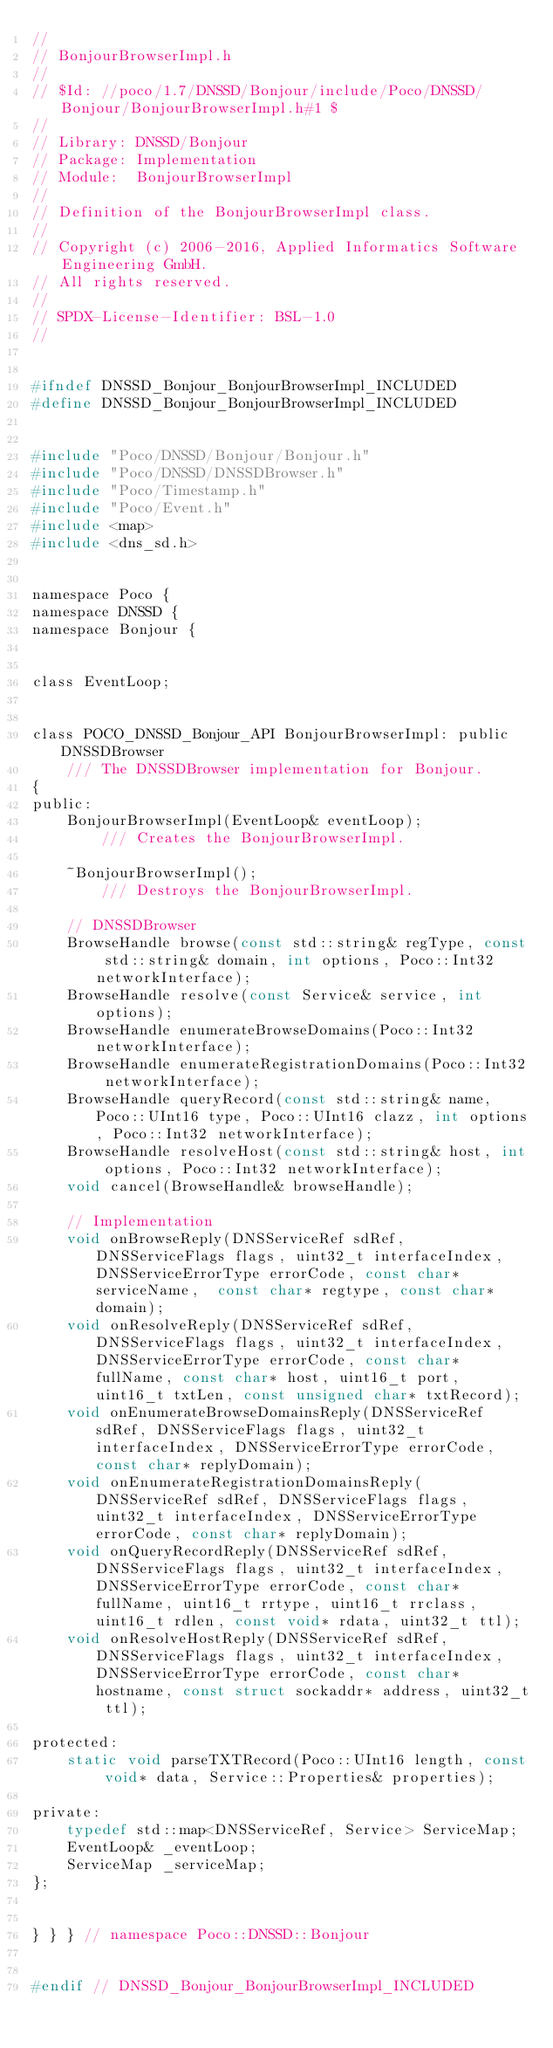<code> <loc_0><loc_0><loc_500><loc_500><_C_>//
// BonjourBrowserImpl.h
//
// $Id: //poco/1.7/DNSSD/Bonjour/include/Poco/DNSSD/Bonjour/BonjourBrowserImpl.h#1 $
//
// Library: DNSSD/Bonjour
// Package: Implementation
// Module:  BonjourBrowserImpl
//
// Definition of the BonjourBrowserImpl class.
//
// Copyright (c) 2006-2016, Applied Informatics Software Engineering GmbH.
// All rights reserved.
//
// SPDX-License-Identifier:	BSL-1.0
//


#ifndef DNSSD_Bonjour_BonjourBrowserImpl_INCLUDED
#define DNSSD_Bonjour_BonjourBrowserImpl_INCLUDED


#include "Poco/DNSSD/Bonjour/Bonjour.h"
#include "Poco/DNSSD/DNSSDBrowser.h"
#include "Poco/Timestamp.h"
#include "Poco/Event.h"
#include <map>
#include <dns_sd.h>


namespace Poco {
namespace DNSSD {
namespace Bonjour {


class EventLoop;


class POCO_DNSSD_Bonjour_API BonjourBrowserImpl: public DNSSDBrowser
	/// The DNSSDBrowser implementation for Bonjour.
{
public:
	BonjourBrowserImpl(EventLoop& eventLoop);
		/// Creates the BonjourBrowserImpl.
		
	~BonjourBrowserImpl();
		/// Destroys the BonjourBrowserImpl.
		
	// DNSSDBrowser
	BrowseHandle browse(const std::string& regType, const std::string& domain, int options, Poco::Int32 networkInterface);
	BrowseHandle resolve(const Service& service, int options);
	BrowseHandle enumerateBrowseDomains(Poco::Int32 networkInterface);
	BrowseHandle enumerateRegistrationDomains(Poco::Int32 networkInterface);
	BrowseHandle queryRecord(const std::string& name, Poco::UInt16 type, Poco::UInt16 clazz, int options, Poco::Int32 networkInterface);
	BrowseHandle resolveHost(const std::string& host, int options, Poco::Int32 networkInterface);
	void cancel(BrowseHandle& browseHandle);
	
	// Implementation
	void onBrowseReply(DNSServiceRef sdRef, DNSServiceFlags flags, uint32_t interfaceIndex, DNSServiceErrorType errorCode, const char* serviceName,  const char* regtype, const char* domain);
	void onResolveReply(DNSServiceRef sdRef, DNSServiceFlags flags, uint32_t interfaceIndex, DNSServiceErrorType errorCode, const char* fullName, const char* host, uint16_t port, uint16_t txtLen, const unsigned char* txtRecord);
	void onEnumerateBrowseDomainsReply(DNSServiceRef sdRef, DNSServiceFlags flags, uint32_t interfaceIndex, DNSServiceErrorType errorCode, const char* replyDomain);
	void onEnumerateRegistrationDomainsReply(DNSServiceRef sdRef, DNSServiceFlags flags, uint32_t interfaceIndex, DNSServiceErrorType errorCode, const char* replyDomain);
    void onQueryRecordReply(DNSServiceRef sdRef, DNSServiceFlags flags, uint32_t interfaceIndex, DNSServiceErrorType errorCode, const char* fullName, uint16_t rrtype, uint16_t rrclass, uint16_t rdlen, const void* rdata, uint32_t ttl);
	void onResolveHostReply(DNSServiceRef sdRef, DNSServiceFlags flags, uint32_t interfaceIndex, DNSServiceErrorType errorCode, const char* hostname, const struct sockaddr* address, uint32_t ttl);

protected:
	static void parseTXTRecord(Poco::UInt16 length, const void* data, Service::Properties& properties);

private:
	typedef std::map<DNSServiceRef, Service> ServiceMap;
	EventLoop& _eventLoop;
	ServiceMap _serviceMap;
};


} } } // namespace Poco::DNSSD::Bonjour


#endif // DNSSD_Bonjour_BonjourBrowserImpl_INCLUDED
</code> 